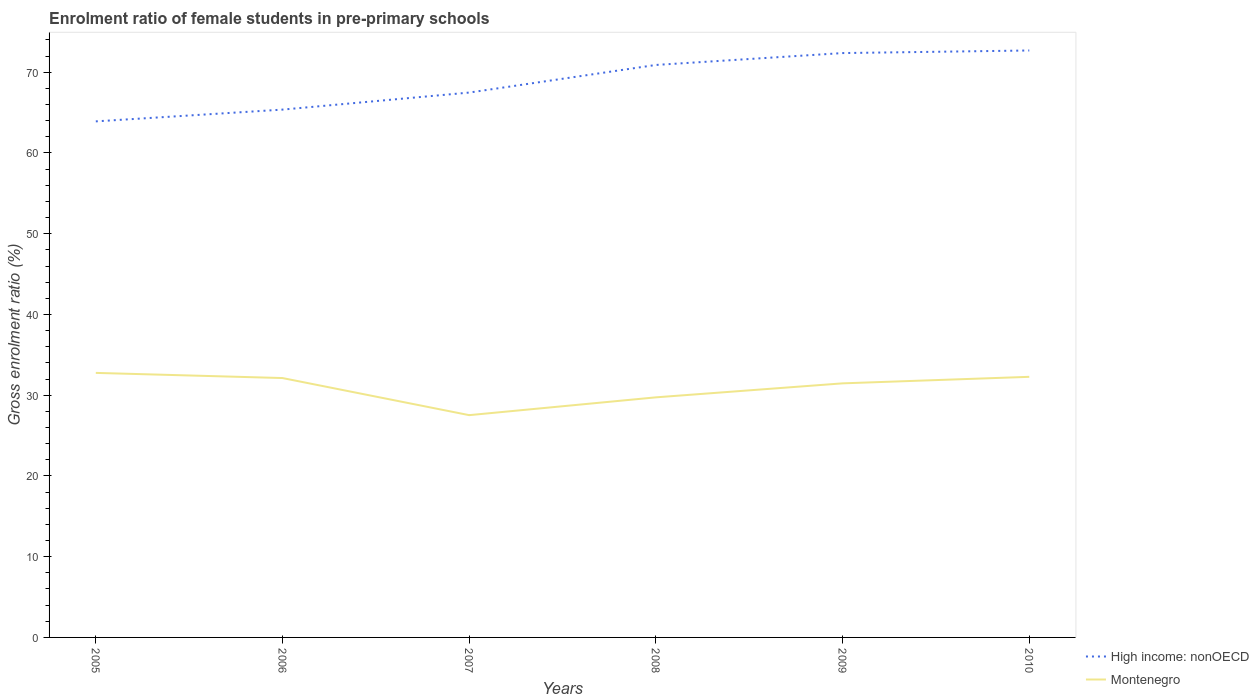How many different coloured lines are there?
Your response must be concise. 2. Across all years, what is the maximum enrolment ratio of female students in pre-primary schools in High income: nonOECD?
Provide a short and direct response. 63.91. What is the total enrolment ratio of female students in pre-primary schools in High income: nonOECD in the graph?
Ensure brevity in your answer.  -3.57. What is the difference between the highest and the second highest enrolment ratio of female students in pre-primary schools in Montenegro?
Ensure brevity in your answer.  5.23. Is the enrolment ratio of female students in pre-primary schools in High income: nonOECD strictly greater than the enrolment ratio of female students in pre-primary schools in Montenegro over the years?
Your response must be concise. No. Are the values on the major ticks of Y-axis written in scientific E-notation?
Make the answer very short. No. How many legend labels are there?
Your answer should be very brief. 2. How are the legend labels stacked?
Your response must be concise. Vertical. What is the title of the graph?
Offer a terse response. Enrolment ratio of female students in pre-primary schools. Does "Middle East & North Africa (all income levels)" appear as one of the legend labels in the graph?
Make the answer very short. No. What is the Gross enrolment ratio (%) in High income: nonOECD in 2005?
Your answer should be compact. 63.91. What is the Gross enrolment ratio (%) in Montenegro in 2005?
Provide a succinct answer. 32.76. What is the Gross enrolment ratio (%) of High income: nonOECD in 2006?
Provide a succinct answer. 65.37. What is the Gross enrolment ratio (%) in Montenegro in 2006?
Your response must be concise. 32.12. What is the Gross enrolment ratio (%) in High income: nonOECD in 2007?
Make the answer very short. 67.48. What is the Gross enrolment ratio (%) of Montenegro in 2007?
Offer a terse response. 27.53. What is the Gross enrolment ratio (%) of High income: nonOECD in 2008?
Provide a succinct answer. 70.9. What is the Gross enrolment ratio (%) in Montenegro in 2008?
Provide a succinct answer. 29.73. What is the Gross enrolment ratio (%) of High income: nonOECD in 2009?
Give a very brief answer. 72.37. What is the Gross enrolment ratio (%) of Montenegro in 2009?
Your response must be concise. 31.47. What is the Gross enrolment ratio (%) in High income: nonOECD in 2010?
Give a very brief answer. 72.69. What is the Gross enrolment ratio (%) in Montenegro in 2010?
Keep it short and to the point. 32.28. Across all years, what is the maximum Gross enrolment ratio (%) of High income: nonOECD?
Your response must be concise. 72.69. Across all years, what is the maximum Gross enrolment ratio (%) in Montenegro?
Keep it short and to the point. 32.76. Across all years, what is the minimum Gross enrolment ratio (%) of High income: nonOECD?
Offer a very short reply. 63.91. Across all years, what is the minimum Gross enrolment ratio (%) in Montenegro?
Offer a very short reply. 27.53. What is the total Gross enrolment ratio (%) of High income: nonOECD in the graph?
Your response must be concise. 412.74. What is the total Gross enrolment ratio (%) of Montenegro in the graph?
Offer a terse response. 185.9. What is the difference between the Gross enrolment ratio (%) of High income: nonOECD in 2005 and that in 2006?
Your answer should be compact. -1.46. What is the difference between the Gross enrolment ratio (%) in Montenegro in 2005 and that in 2006?
Keep it short and to the point. 0.64. What is the difference between the Gross enrolment ratio (%) in High income: nonOECD in 2005 and that in 2007?
Your answer should be compact. -3.57. What is the difference between the Gross enrolment ratio (%) in Montenegro in 2005 and that in 2007?
Provide a short and direct response. 5.23. What is the difference between the Gross enrolment ratio (%) of High income: nonOECD in 2005 and that in 2008?
Keep it short and to the point. -6.99. What is the difference between the Gross enrolment ratio (%) in Montenegro in 2005 and that in 2008?
Ensure brevity in your answer.  3.03. What is the difference between the Gross enrolment ratio (%) of High income: nonOECD in 2005 and that in 2009?
Your answer should be very brief. -8.46. What is the difference between the Gross enrolment ratio (%) of Montenegro in 2005 and that in 2009?
Make the answer very short. 1.3. What is the difference between the Gross enrolment ratio (%) in High income: nonOECD in 2005 and that in 2010?
Make the answer very short. -8.78. What is the difference between the Gross enrolment ratio (%) in Montenegro in 2005 and that in 2010?
Make the answer very short. 0.49. What is the difference between the Gross enrolment ratio (%) in High income: nonOECD in 2006 and that in 2007?
Your answer should be very brief. -2.11. What is the difference between the Gross enrolment ratio (%) of Montenegro in 2006 and that in 2007?
Keep it short and to the point. 4.59. What is the difference between the Gross enrolment ratio (%) of High income: nonOECD in 2006 and that in 2008?
Give a very brief answer. -5.53. What is the difference between the Gross enrolment ratio (%) of Montenegro in 2006 and that in 2008?
Provide a short and direct response. 2.39. What is the difference between the Gross enrolment ratio (%) of High income: nonOECD in 2006 and that in 2009?
Offer a very short reply. -7. What is the difference between the Gross enrolment ratio (%) of Montenegro in 2006 and that in 2009?
Offer a terse response. 0.66. What is the difference between the Gross enrolment ratio (%) in High income: nonOECD in 2006 and that in 2010?
Offer a very short reply. -7.32. What is the difference between the Gross enrolment ratio (%) of Montenegro in 2006 and that in 2010?
Make the answer very short. -0.15. What is the difference between the Gross enrolment ratio (%) of High income: nonOECD in 2007 and that in 2008?
Your response must be concise. -3.42. What is the difference between the Gross enrolment ratio (%) in Montenegro in 2007 and that in 2008?
Your response must be concise. -2.2. What is the difference between the Gross enrolment ratio (%) in High income: nonOECD in 2007 and that in 2009?
Keep it short and to the point. -4.89. What is the difference between the Gross enrolment ratio (%) of Montenegro in 2007 and that in 2009?
Offer a very short reply. -3.94. What is the difference between the Gross enrolment ratio (%) of High income: nonOECD in 2007 and that in 2010?
Ensure brevity in your answer.  -5.21. What is the difference between the Gross enrolment ratio (%) of Montenegro in 2007 and that in 2010?
Offer a very short reply. -4.75. What is the difference between the Gross enrolment ratio (%) of High income: nonOECD in 2008 and that in 2009?
Your response must be concise. -1.47. What is the difference between the Gross enrolment ratio (%) of Montenegro in 2008 and that in 2009?
Give a very brief answer. -1.73. What is the difference between the Gross enrolment ratio (%) in High income: nonOECD in 2008 and that in 2010?
Your response must be concise. -1.79. What is the difference between the Gross enrolment ratio (%) in Montenegro in 2008 and that in 2010?
Provide a short and direct response. -2.54. What is the difference between the Gross enrolment ratio (%) of High income: nonOECD in 2009 and that in 2010?
Your response must be concise. -0.32. What is the difference between the Gross enrolment ratio (%) of Montenegro in 2009 and that in 2010?
Ensure brevity in your answer.  -0.81. What is the difference between the Gross enrolment ratio (%) in High income: nonOECD in 2005 and the Gross enrolment ratio (%) in Montenegro in 2006?
Your response must be concise. 31.79. What is the difference between the Gross enrolment ratio (%) of High income: nonOECD in 2005 and the Gross enrolment ratio (%) of Montenegro in 2007?
Ensure brevity in your answer.  36.38. What is the difference between the Gross enrolment ratio (%) in High income: nonOECD in 2005 and the Gross enrolment ratio (%) in Montenegro in 2008?
Give a very brief answer. 34.18. What is the difference between the Gross enrolment ratio (%) in High income: nonOECD in 2005 and the Gross enrolment ratio (%) in Montenegro in 2009?
Offer a terse response. 32.45. What is the difference between the Gross enrolment ratio (%) of High income: nonOECD in 2005 and the Gross enrolment ratio (%) of Montenegro in 2010?
Your answer should be very brief. 31.64. What is the difference between the Gross enrolment ratio (%) of High income: nonOECD in 2006 and the Gross enrolment ratio (%) of Montenegro in 2007?
Give a very brief answer. 37.84. What is the difference between the Gross enrolment ratio (%) of High income: nonOECD in 2006 and the Gross enrolment ratio (%) of Montenegro in 2008?
Provide a short and direct response. 35.64. What is the difference between the Gross enrolment ratio (%) of High income: nonOECD in 2006 and the Gross enrolment ratio (%) of Montenegro in 2009?
Offer a terse response. 33.9. What is the difference between the Gross enrolment ratio (%) in High income: nonOECD in 2006 and the Gross enrolment ratio (%) in Montenegro in 2010?
Keep it short and to the point. 33.1. What is the difference between the Gross enrolment ratio (%) in High income: nonOECD in 2007 and the Gross enrolment ratio (%) in Montenegro in 2008?
Give a very brief answer. 37.75. What is the difference between the Gross enrolment ratio (%) of High income: nonOECD in 2007 and the Gross enrolment ratio (%) of Montenegro in 2009?
Give a very brief answer. 36.01. What is the difference between the Gross enrolment ratio (%) in High income: nonOECD in 2007 and the Gross enrolment ratio (%) in Montenegro in 2010?
Keep it short and to the point. 35.21. What is the difference between the Gross enrolment ratio (%) in High income: nonOECD in 2008 and the Gross enrolment ratio (%) in Montenegro in 2009?
Offer a terse response. 39.43. What is the difference between the Gross enrolment ratio (%) of High income: nonOECD in 2008 and the Gross enrolment ratio (%) of Montenegro in 2010?
Provide a succinct answer. 38.63. What is the difference between the Gross enrolment ratio (%) in High income: nonOECD in 2009 and the Gross enrolment ratio (%) in Montenegro in 2010?
Your answer should be very brief. 40.1. What is the average Gross enrolment ratio (%) in High income: nonOECD per year?
Offer a very short reply. 68.79. What is the average Gross enrolment ratio (%) in Montenegro per year?
Your answer should be very brief. 30.98. In the year 2005, what is the difference between the Gross enrolment ratio (%) in High income: nonOECD and Gross enrolment ratio (%) in Montenegro?
Make the answer very short. 31.15. In the year 2006, what is the difference between the Gross enrolment ratio (%) in High income: nonOECD and Gross enrolment ratio (%) in Montenegro?
Provide a succinct answer. 33.25. In the year 2007, what is the difference between the Gross enrolment ratio (%) in High income: nonOECD and Gross enrolment ratio (%) in Montenegro?
Your response must be concise. 39.95. In the year 2008, what is the difference between the Gross enrolment ratio (%) in High income: nonOECD and Gross enrolment ratio (%) in Montenegro?
Your answer should be compact. 41.17. In the year 2009, what is the difference between the Gross enrolment ratio (%) in High income: nonOECD and Gross enrolment ratio (%) in Montenegro?
Make the answer very short. 40.91. In the year 2010, what is the difference between the Gross enrolment ratio (%) of High income: nonOECD and Gross enrolment ratio (%) of Montenegro?
Ensure brevity in your answer.  40.42. What is the ratio of the Gross enrolment ratio (%) in High income: nonOECD in 2005 to that in 2006?
Keep it short and to the point. 0.98. What is the ratio of the Gross enrolment ratio (%) in Montenegro in 2005 to that in 2006?
Ensure brevity in your answer.  1.02. What is the ratio of the Gross enrolment ratio (%) of High income: nonOECD in 2005 to that in 2007?
Keep it short and to the point. 0.95. What is the ratio of the Gross enrolment ratio (%) of Montenegro in 2005 to that in 2007?
Offer a terse response. 1.19. What is the ratio of the Gross enrolment ratio (%) in High income: nonOECD in 2005 to that in 2008?
Offer a terse response. 0.9. What is the ratio of the Gross enrolment ratio (%) in Montenegro in 2005 to that in 2008?
Your answer should be compact. 1.1. What is the ratio of the Gross enrolment ratio (%) of High income: nonOECD in 2005 to that in 2009?
Your answer should be compact. 0.88. What is the ratio of the Gross enrolment ratio (%) in Montenegro in 2005 to that in 2009?
Offer a very short reply. 1.04. What is the ratio of the Gross enrolment ratio (%) in High income: nonOECD in 2005 to that in 2010?
Offer a terse response. 0.88. What is the ratio of the Gross enrolment ratio (%) in Montenegro in 2005 to that in 2010?
Give a very brief answer. 1.02. What is the ratio of the Gross enrolment ratio (%) in High income: nonOECD in 2006 to that in 2007?
Keep it short and to the point. 0.97. What is the ratio of the Gross enrolment ratio (%) in Montenegro in 2006 to that in 2007?
Offer a very short reply. 1.17. What is the ratio of the Gross enrolment ratio (%) in High income: nonOECD in 2006 to that in 2008?
Provide a short and direct response. 0.92. What is the ratio of the Gross enrolment ratio (%) in Montenegro in 2006 to that in 2008?
Offer a very short reply. 1.08. What is the ratio of the Gross enrolment ratio (%) of High income: nonOECD in 2006 to that in 2009?
Provide a short and direct response. 0.9. What is the ratio of the Gross enrolment ratio (%) of Montenegro in 2006 to that in 2009?
Ensure brevity in your answer.  1.02. What is the ratio of the Gross enrolment ratio (%) in High income: nonOECD in 2006 to that in 2010?
Make the answer very short. 0.9. What is the ratio of the Gross enrolment ratio (%) in Montenegro in 2006 to that in 2010?
Your answer should be very brief. 1. What is the ratio of the Gross enrolment ratio (%) of High income: nonOECD in 2007 to that in 2008?
Make the answer very short. 0.95. What is the ratio of the Gross enrolment ratio (%) in Montenegro in 2007 to that in 2008?
Your response must be concise. 0.93. What is the ratio of the Gross enrolment ratio (%) in High income: nonOECD in 2007 to that in 2009?
Your answer should be compact. 0.93. What is the ratio of the Gross enrolment ratio (%) in Montenegro in 2007 to that in 2009?
Provide a short and direct response. 0.87. What is the ratio of the Gross enrolment ratio (%) in High income: nonOECD in 2007 to that in 2010?
Ensure brevity in your answer.  0.93. What is the ratio of the Gross enrolment ratio (%) of Montenegro in 2007 to that in 2010?
Keep it short and to the point. 0.85. What is the ratio of the Gross enrolment ratio (%) of High income: nonOECD in 2008 to that in 2009?
Your answer should be compact. 0.98. What is the ratio of the Gross enrolment ratio (%) in Montenegro in 2008 to that in 2009?
Offer a terse response. 0.94. What is the ratio of the Gross enrolment ratio (%) in High income: nonOECD in 2008 to that in 2010?
Keep it short and to the point. 0.98. What is the ratio of the Gross enrolment ratio (%) of Montenegro in 2008 to that in 2010?
Your answer should be compact. 0.92. What is the ratio of the Gross enrolment ratio (%) in Montenegro in 2009 to that in 2010?
Offer a terse response. 0.97. What is the difference between the highest and the second highest Gross enrolment ratio (%) of High income: nonOECD?
Give a very brief answer. 0.32. What is the difference between the highest and the second highest Gross enrolment ratio (%) in Montenegro?
Your answer should be compact. 0.49. What is the difference between the highest and the lowest Gross enrolment ratio (%) of High income: nonOECD?
Provide a succinct answer. 8.78. What is the difference between the highest and the lowest Gross enrolment ratio (%) in Montenegro?
Ensure brevity in your answer.  5.23. 